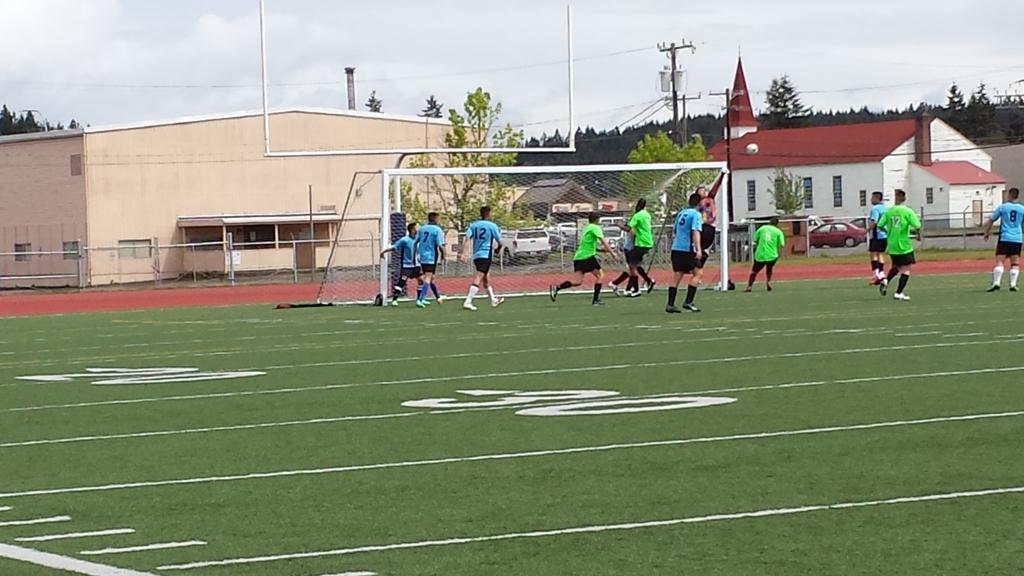Describe this image in one or two sentences. In the image there are a group of football players moving around the ground and behind the ground there are few houses and trees. 